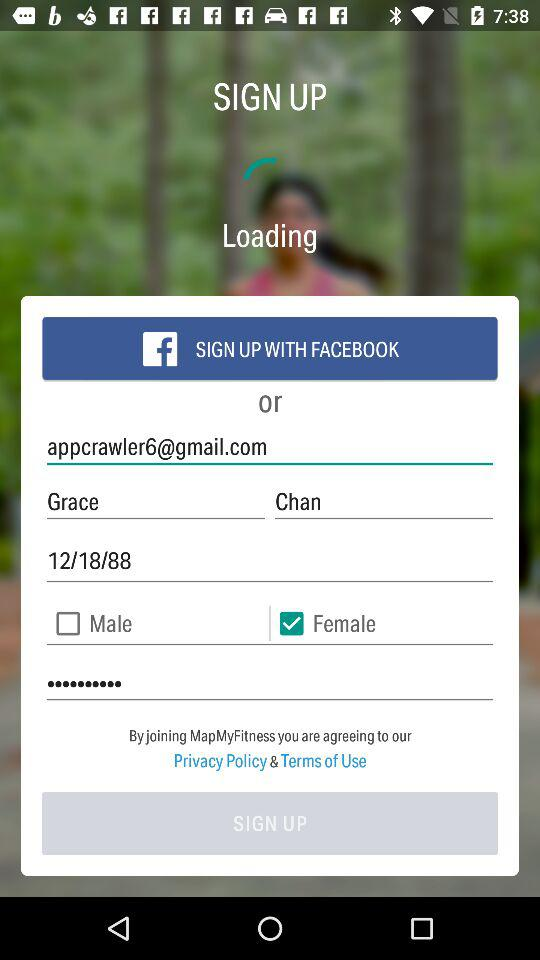What is the date of birth? The date of birth is December 18, 1988. 